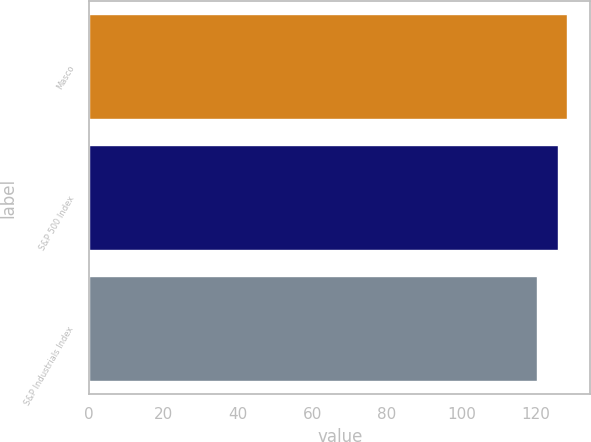Convert chart. <chart><loc_0><loc_0><loc_500><loc_500><bar_chart><fcel>Masco<fcel>S&P 500 Index<fcel>S&P Industrials Index<nl><fcel>128.21<fcel>125.92<fcel>120.19<nl></chart> 